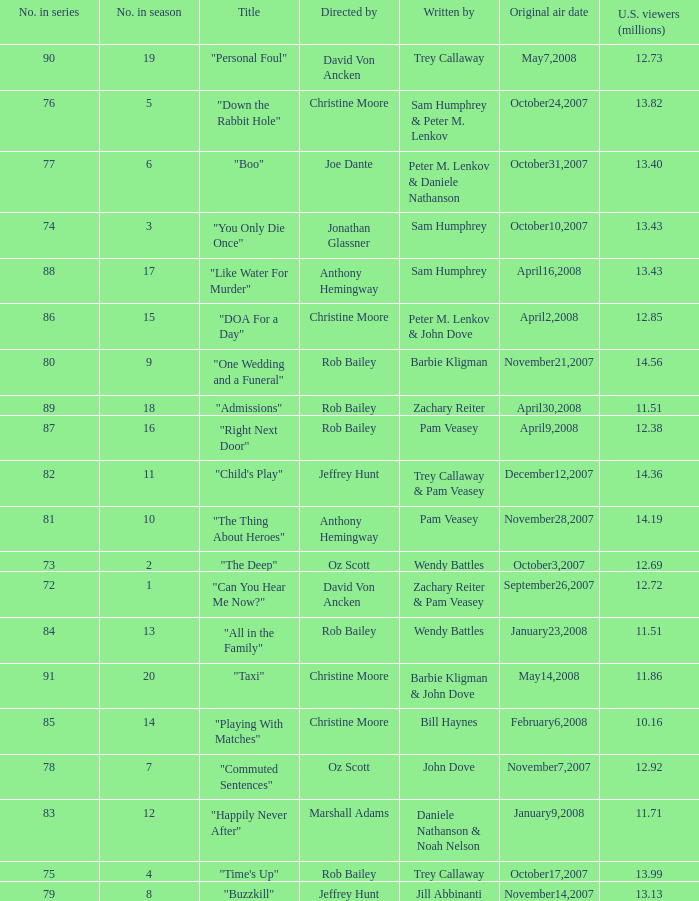How many episodes were watched by 12.72 million U.S. viewers? 1.0. 